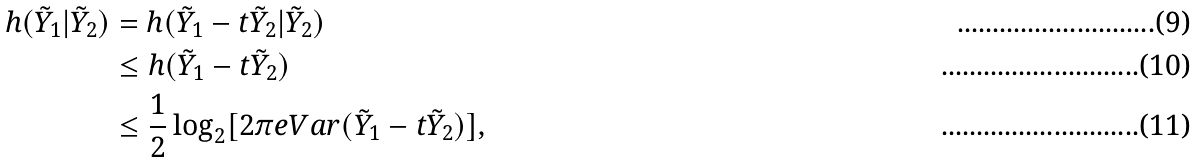Convert formula to latex. <formula><loc_0><loc_0><loc_500><loc_500>h ( \tilde { Y } _ { 1 } | \tilde { Y } _ { 2 } ) & = h ( \tilde { Y } _ { 1 } - t \tilde { Y } _ { 2 } | \tilde { Y } _ { 2 } ) \\ & \leq h ( \tilde { Y } _ { 1 } - t \tilde { Y } _ { 2 } ) \\ & \leq \frac { 1 } { 2 } \log _ { 2 } [ 2 \pi e V a r ( \tilde { Y } _ { 1 } - t \tilde { Y } _ { 2 } ) ] ,</formula> 